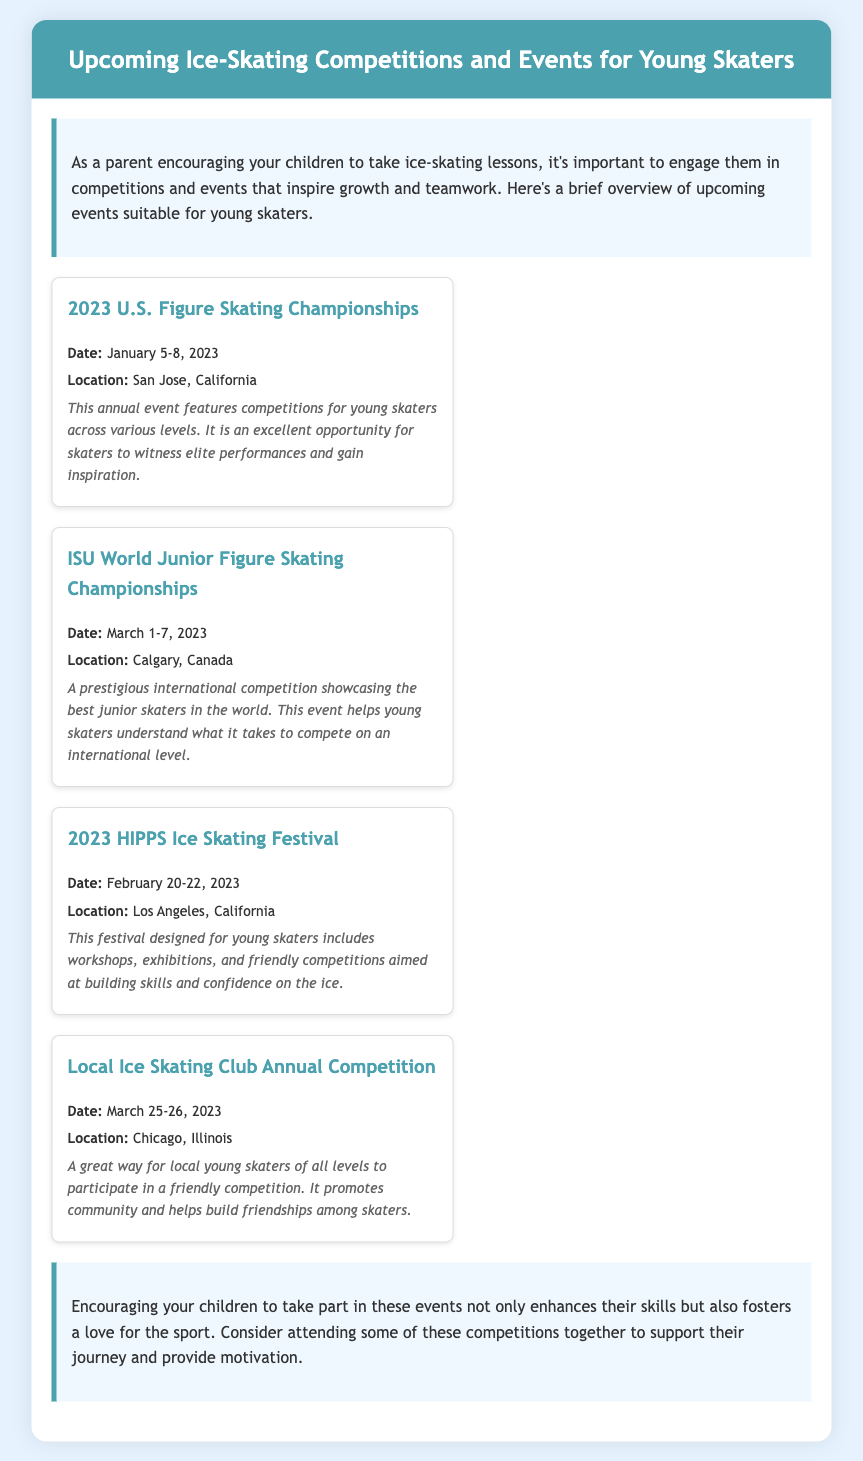What is the title of the memo? The title of the memo is prominently displayed at the top of the document.
Answer: Upcoming Ice-Skating Competitions and Events for Young Skaters When is the 2023 U.S. Figure Skating Championships? The event date is mentioned in the section detailing the U.S. Championships.
Answer: January 5-8, 2023 Where is the ISU World Junior Figure Skating Championships taking place? The location is specified in the details for the event.
Answer: Calgary, Canada What type of event is the 2023 HIPPS Ice Skating Festival? The description indicates the focus and nature of the festival.
Answer: workshops, exhibitions, and friendly competitions Why is the Local Ice Skating Club Annual Competition beneficial for skaters? The memo explains the purpose of the competition in the context of community and friendship.
Answer: promotes community and helps build friendships What is one way for parents to support their children's journey in ice skating according to the conclusion? The conclusion suggests activities that parents can do with their children at events.
Answer: attending competitions together How many events are listed in the document? The total number of events can be counted in the events section.
Answer: Four What is the main purpose of the memo? The introduction provides context on the memo’s overall intent.
Answer: engage young skaters in competitions and events 